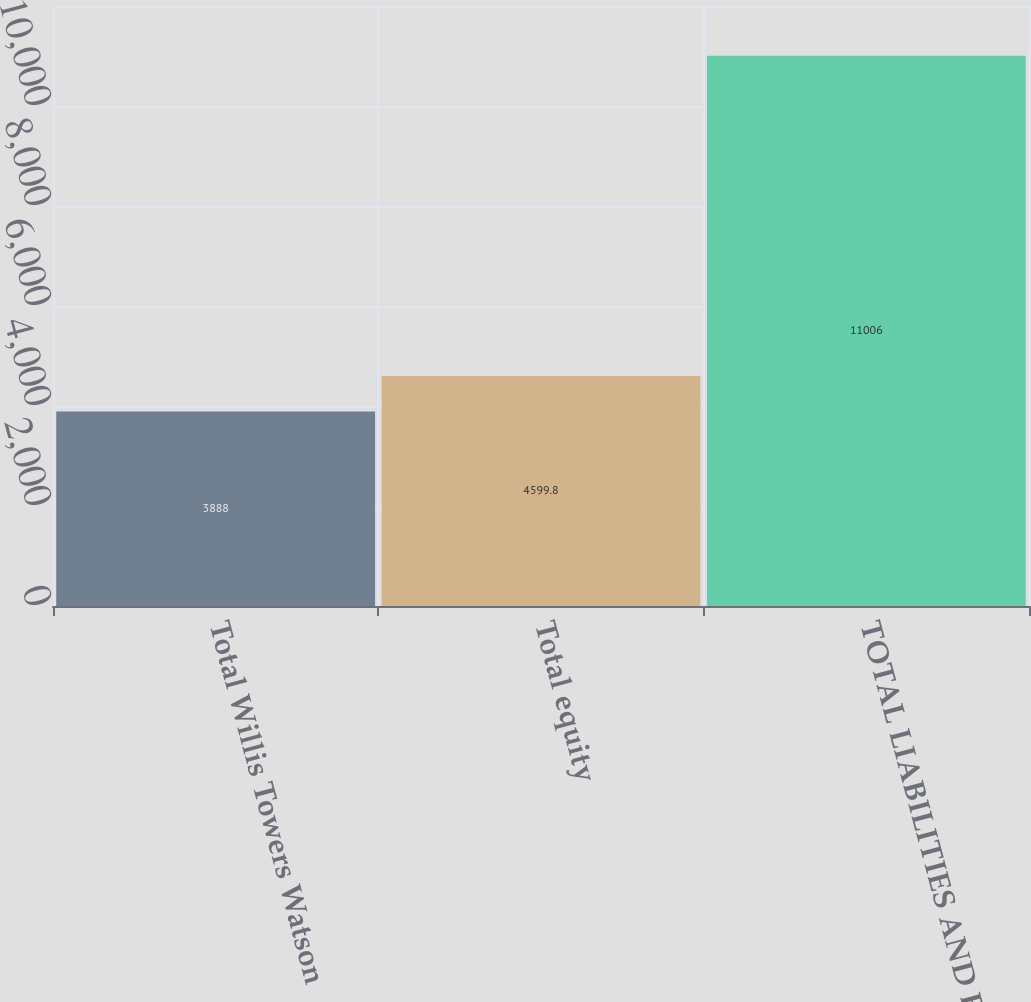<chart> <loc_0><loc_0><loc_500><loc_500><bar_chart><fcel>Total Willis Towers Watson<fcel>Total equity<fcel>TOTAL LIABILITIES AND EQUITY<nl><fcel>3888<fcel>4599.8<fcel>11006<nl></chart> 